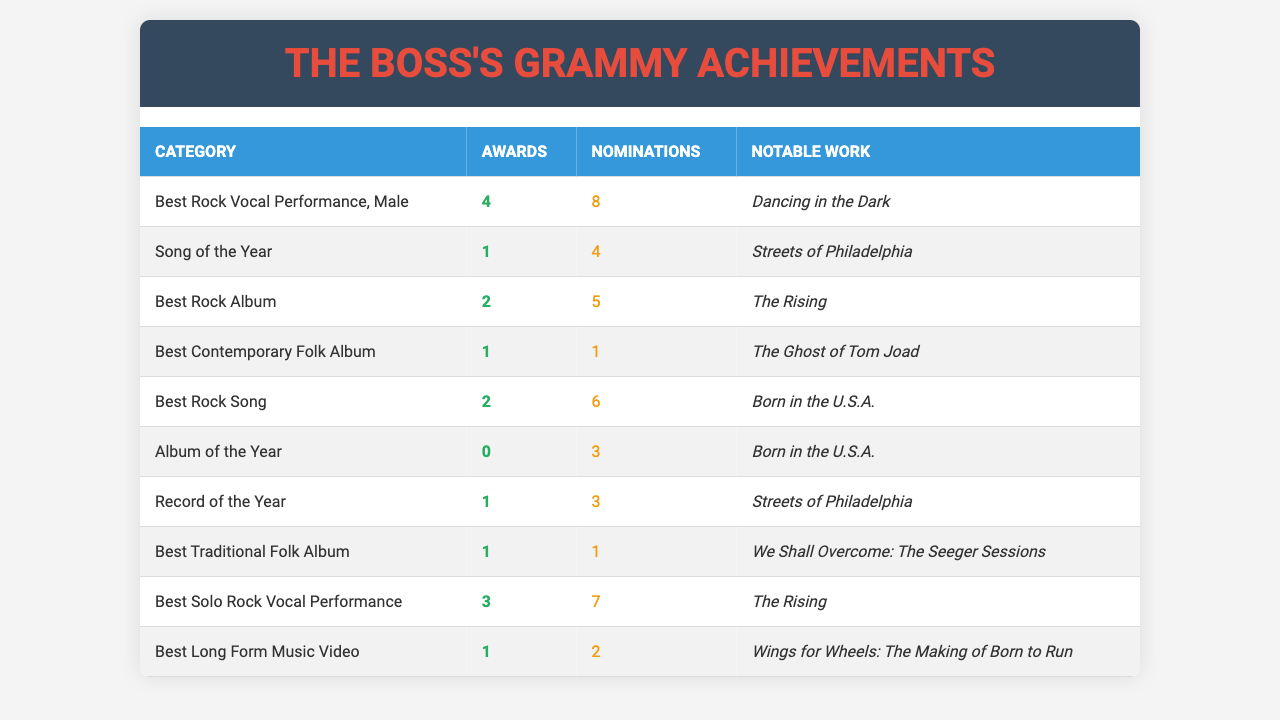What is the total number of Grammy Awards Bruce Springsteen has won in the "Best Rock Vocal Performance, Male" category? Bruce Springsteen has won 4 Grammy Awards in this category.
Answer: 4 How many Grammy nominations does Bruce Springsteen have for "Song of the Year"? Bruce Springsteen has received 4 nominations for "Song of the Year".
Answer: 4 Which category has the highest number of nominations? The "Best Solo Rock Vocal Performance" category has 7 nominations, which is the highest among all categories.
Answer: 7 Did Bruce Springsteen win any Grammy Awards in the "Album of the Year" category? No, he did not win any awards in the "Album of the Year" category; he has 0 wins.
Answer: No What is the total number of Grammy Awards won by Bruce Springsteen across all categories? Adding the awards won in all categories: 4 + 1 + 2 + 1 + 2 + 0 + 1 + 1 + 3 + 1 = 16 awards in total.
Answer: 16 In which Grammy category is "Dancing in the Dark" notably recognized? "Dancing in the Dark" is recognized in the "Best Rock Vocal Performance, Male" category.
Answer: Best Rock Vocal Performance, Male How many more nominations does Bruce Springsteen have in "Best Rock Song" than in "Best Contemporary Folk Album"? He has 6 nominations for "Best Rock Song" and 1 nomination for "Best Contemporary Folk Album", resulting in a difference of 5 nominations.
Answer: 5 Identify the notable work associated with "Record of the Year". The notable work associated with "Record of the Year" is "Streets of Philadelphia."
Answer: Streets of Philadelphia What is the average number of awards Bruce Springsteen has won per category based on the data provided? He has won a total of 16 awards across 10 categories, so the average is 16/10 = 1.6 awards per category.
Answer: 1.6 Is there any category where Bruce Springsteen has the same number of awards as nominations? Yes, in the "Best Contemporary Folk Album" category, he has 1 award and 1 nomination.
Answer: Yes 